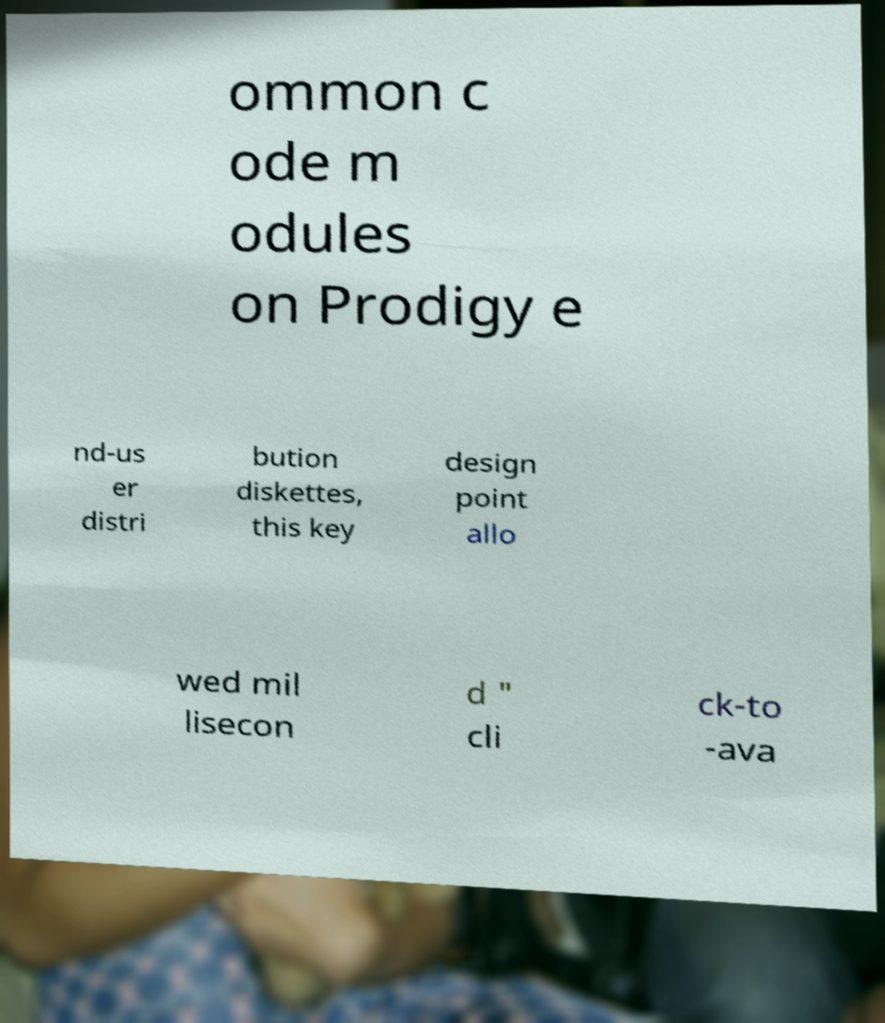Could you assist in decoding the text presented in this image and type it out clearly? ommon c ode m odules on Prodigy e nd-us er distri bution diskettes, this key design point allo wed mil lisecon d " cli ck-to -ava 